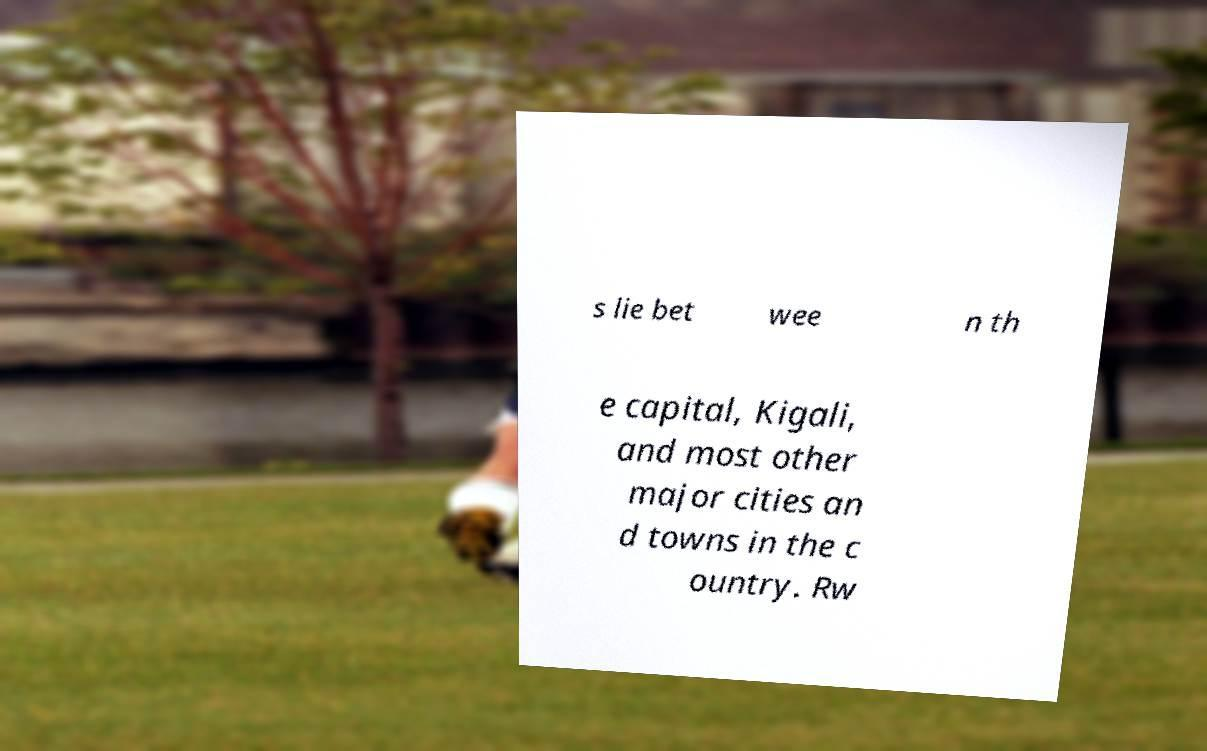Could you extract and type out the text from this image? s lie bet wee n th e capital, Kigali, and most other major cities an d towns in the c ountry. Rw 